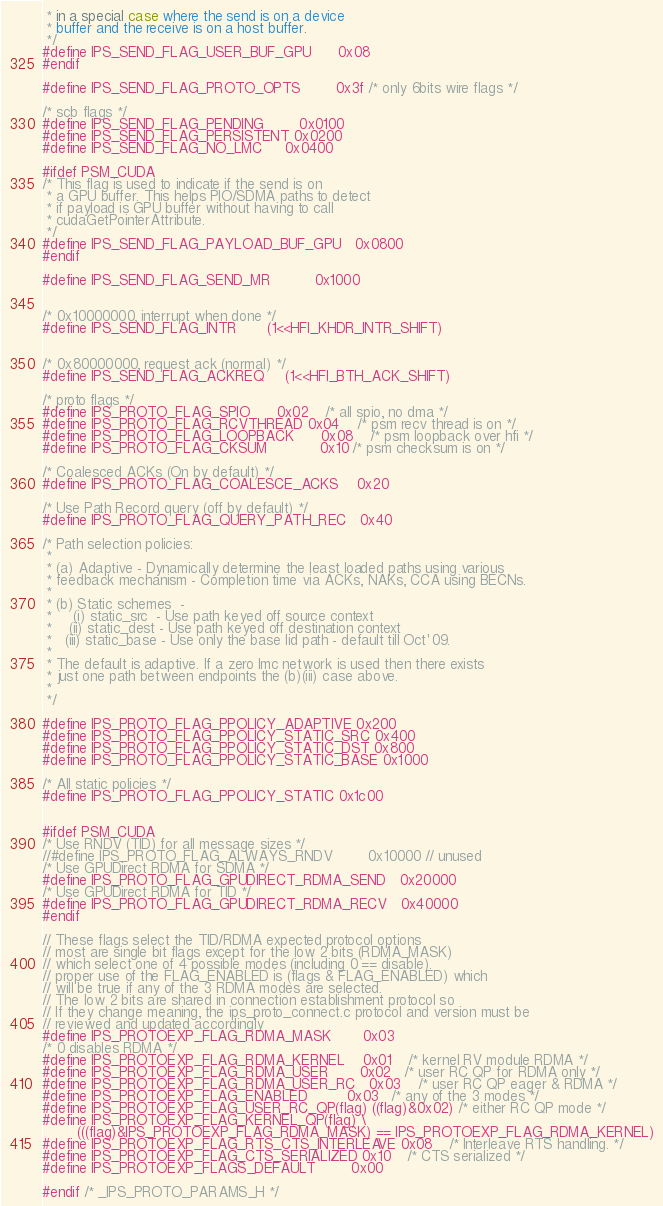Convert code to text. <code><loc_0><loc_0><loc_500><loc_500><_C_> * in a special case where the send is on a device
 * buffer and the receive is on a host buffer.
 */
#define IPS_SEND_FLAG_USER_BUF_GPU      0x08
#endif

#define IPS_SEND_FLAG_PROTO_OPTS        0x3f	/* only 6bits wire flags */

/* scb flags */
#define IPS_SEND_FLAG_PENDING		0x0100
#define IPS_SEND_FLAG_PERSISTENT	0x0200
#define IPS_SEND_FLAG_NO_LMC		0x0400

#ifdef PSM_CUDA
/* This flag is used to indicate if the send is on
 * a GPU buffer. This helps PIO/SDMA paths to detect
 * if payload is GPU buffer without having to call
 * cudaGetPointerAttribute.
 */
#define IPS_SEND_FLAG_PAYLOAD_BUF_GPU   0x0800
#endif

#define IPS_SEND_FLAG_SEND_MR          0x1000


/* 0x10000000, interrupt when done */
#define IPS_SEND_FLAG_INTR		(1<<HFI_KHDR_INTR_SHIFT)


/* 0x80000000, request ack (normal) */
#define IPS_SEND_FLAG_ACKREQ		(1<<HFI_BTH_ACK_SHIFT)

/* proto flags */
#define IPS_PROTO_FLAG_SPIO		0x02	/* all spio, no dma */
#define IPS_PROTO_FLAG_RCVTHREAD	0x04	/* psm recv thread is on */
#define IPS_PROTO_FLAG_LOOPBACK		0x08	/* psm loopback over hfi */
#define IPS_PROTO_FLAG_CKSUM            0x10	/* psm checksum is on */

/* Coalesced ACKs (On by default) */
#define IPS_PROTO_FLAG_COALESCE_ACKS    0x20

/* Use Path Record query (off by default) */
#define IPS_PROTO_FLAG_QUERY_PATH_REC   0x40

/* Path selection policies:
 *
 * (a) Adaptive - Dynamically determine the least loaded paths using various
 * feedback mechanism - Completion time via ACKs, NAKs, CCA using BECNs.
 *
 * (b) Static schemes  -
 *     (i) static_src  - Use path keyed off source context
 *    (ii) static_dest - Use path keyed off destination context
 *   (iii) static_base - Use only the base lid path - default till Oct'09.
 *
 * The default is adaptive. If a zero lmc network is used then there exists
 * just one path between endpoints the (b)(iii) case above.
 *
 */

#define IPS_PROTO_FLAG_PPOLICY_ADAPTIVE 0x200
#define IPS_PROTO_FLAG_PPOLICY_STATIC_SRC 0x400
#define IPS_PROTO_FLAG_PPOLICY_STATIC_DST 0x800
#define IPS_PROTO_FLAG_PPOLICY_STATIC_BASE 0x1000

/* All static policies */
#define IPS_PROTO_FLAG_PPOLICY_STATIC 0x1c00


#ifdef PSM_CUDA
/* Use RNDV (TID) for all message sizes */
//#define IPS_PROTO_FLAG_ALWAYS_RNDV		0x10000	// unused
/* Use GPUDirect RDMA for SDMA */
#define IPS_PROTO_FLAG_GPUDIRECT_RDMA_SEND	0x20000
/* Use GPUDirect RDMA for TID */
#define IPS_PROTO_FLAG_GPUDIRECT_RDMA_RECV	0x40000
#endif

// These flags select the TID/RDMA expected protocol options
// most are single bit flags except for the low 2 bits (RDMA_MASK)
// which select one of 4 possible modes (including 0 == disable).
// proper use of the FLAG_ENABLED is (flags & FLAG_ENABLED) which
// will be true if any of the 3 RDMA modes are selected.
// The low 2 bits are shared in connection establishment protocol so
// If they change meaning, the ips_proto_connect.c protocol and version must be
// reviewed and updated accordingly
#define IPS_PROTOEXP_FLAG_RDMA_MASK	     0x03
/* 0 disables RDMA */
#define IPS_PROTOEXP_FLAG_RDMA_KERNEL    0x01	/* kernel RV module RDMA */
#define IPS_PROTOEXP_FLAG_RDMA_USER	     0x02	/* user RC QP for RDMA only */
#define IPS_PROTOEXP_FLAG_RDMA_USER_RC   0x03	/* user RC QP eager & RDMA */
#define IPS_PROTOEXP_FLAG_ENABLED	     0x03	/* any of the 3 modes */
#define IPS_PROTOEXP_FLAG_USER_RC_QP(flag) ((flag)&0x02) /* either RC QP mode */
#define IPS_PROTOEXP_FLAG_KERNEL_QP(flag) \
		(((flag)&IPS_PROTOEXP_FLAG_RDMA_MASK) == IPS_PROTOEXP_FLAG_RDMA_KERNEL)
#define IPS_PROTOEXP_FLAG_RTS_CTS_INTERLEAVE 0x08	/* Interleave RTS handling. */
#define IPS_PROTOEXP_FLAG_CTS_SERIALIZED 0x10	/* CTS serialized */
#define IPS_PROTOEXP_FLAGS_DEFAULT	     0x00

#endif /* _IPS_PROTO_PARAMS_H */
</code> 